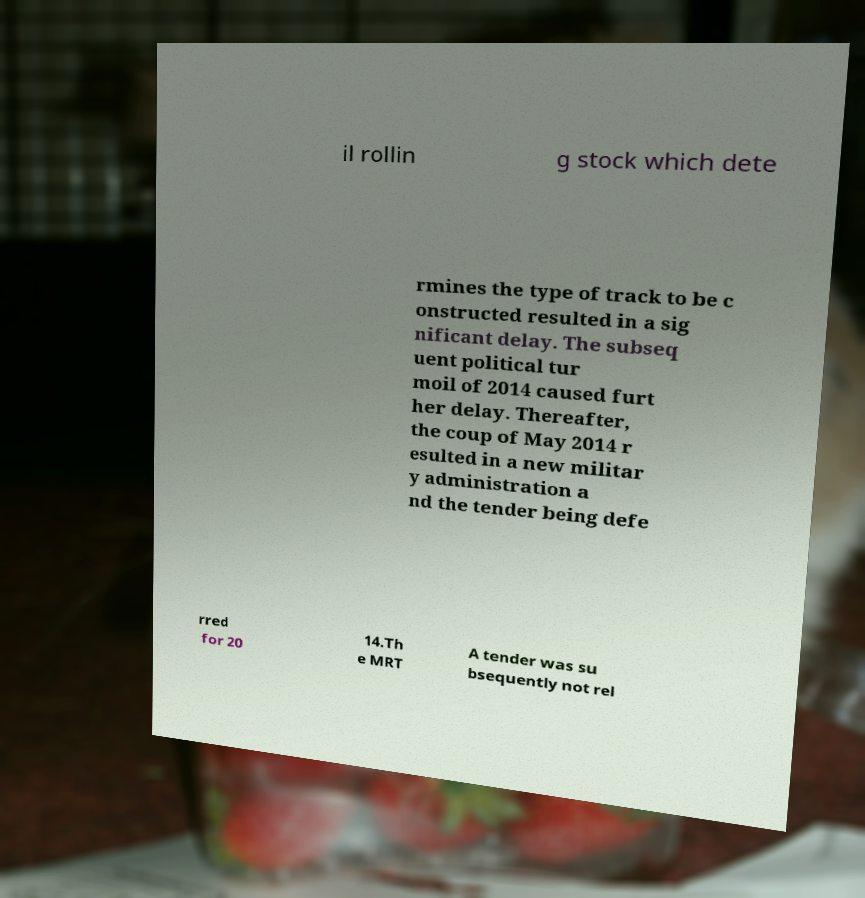Can you accurately transcribe the text from the provided image for me? il rollin g stock which dete rmines the type of track to be c onstructed resulted in a sig nificant delay. The subseq uent political tur moil of 2014 caused furt her delay. Thereafter, the coup of May 2014 r esulted in a new militar y administration a nd the tender being defe rred for 20 14.Th e MRT A tender was su bsequently not rel 